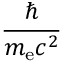<formula> <loc_0><loc_0><loc_500><loc_500>\frac { } { m _ { e } c ^ { 2 } }</formula> 